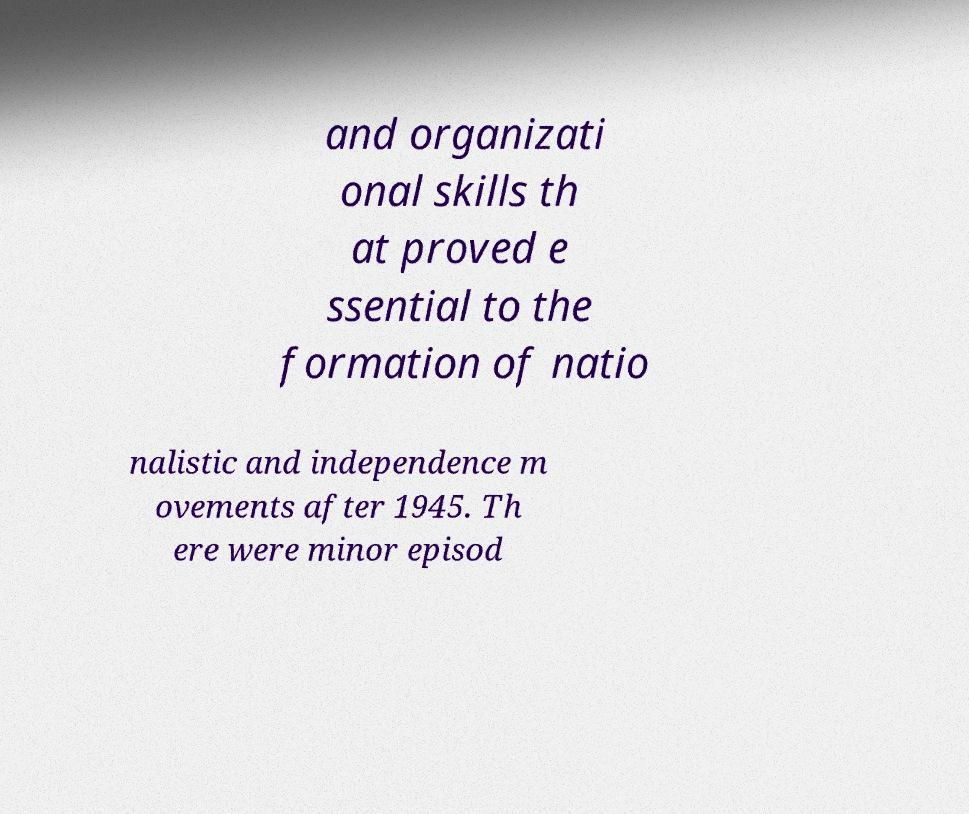For documentation purposes, I need the text within this image transcribed. Could you provide that? and organizati onal skills th at proved e ssential to the formation of natio nalistic and independence m ovements after 1945. Th ere were minor episod 